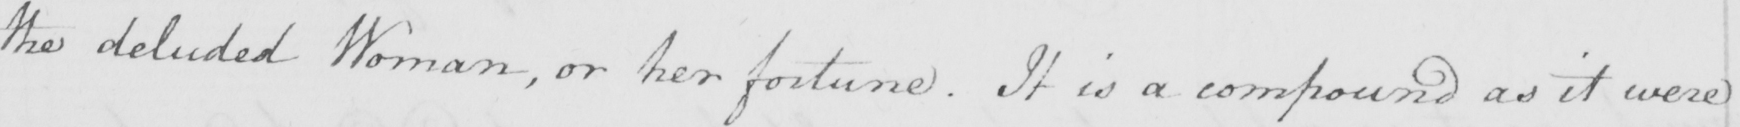Transcribe the text shown in this historical manuscript line. the deluded Woman , or her fortune . It is a compound as it were 